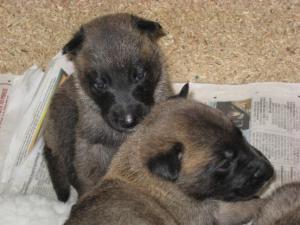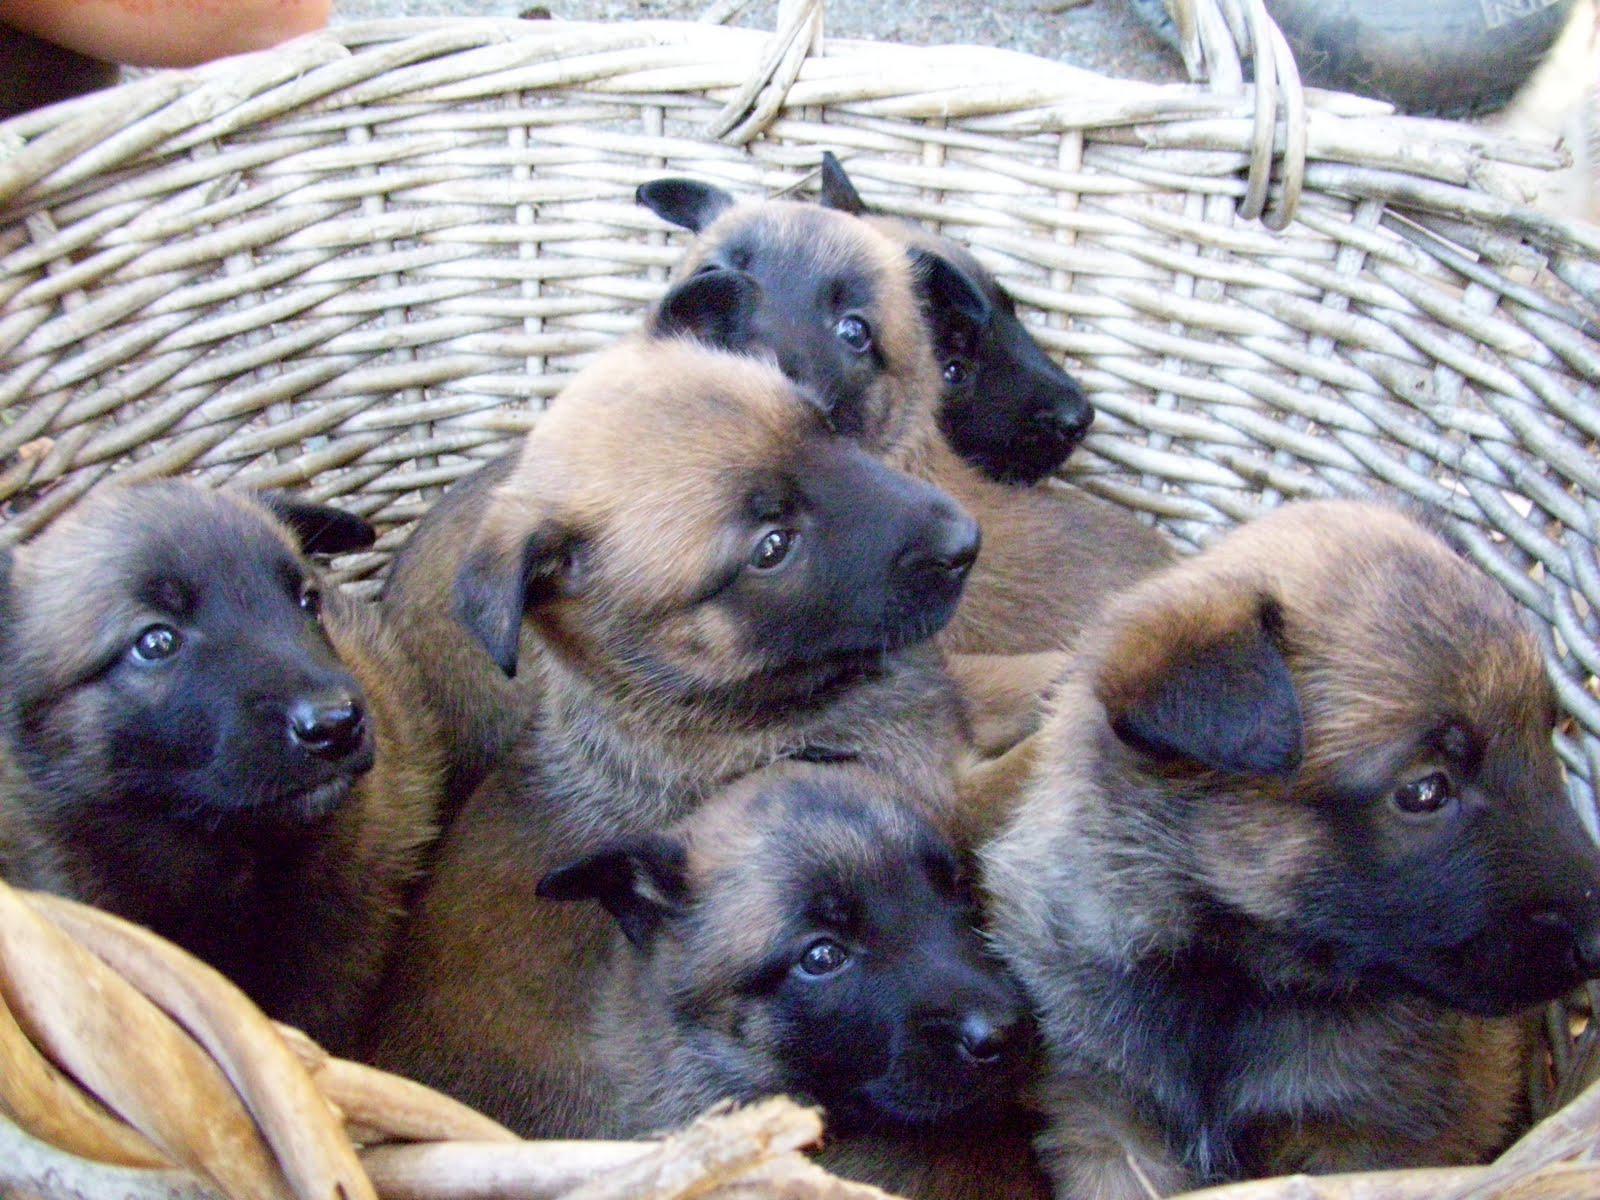The first image is the image on the left, the second image is the image on the right. Analyze the images presented: Is the assertion "There's no more than five dogs in the right image." valid? Answer yes or no. Yes. The first image is the image on the left, the second image is the image on the right. For the images shown, is this caption "An image shows puppies in collars on a blanket, with their heads aimed toward the middle of the group." true? Answer yes or no. No. 